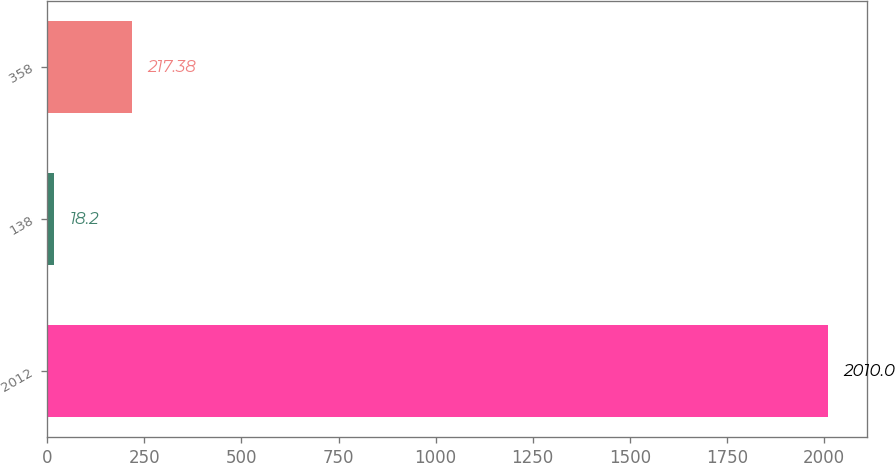<chart> <loc_0><loc_0><loc_500><loc_500><bar_chart><fcel>2012<fcel>138<fcel>358<nl><fcel>2010<fcel>18.2<fcel>217.38<nl></chart> 